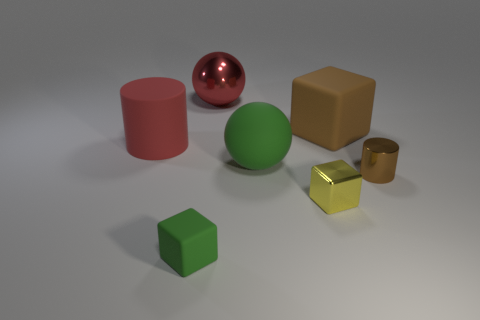Add 3 big red metallic balls. How many objects exist? 10 Subtract all balls. How many objects are left? 5 Subtract 1 green blocks. How many objects are left? 6 Subtract all purple cylinders. Subtract all tiny green cubes. How many objects are left? 6 Add 1 small green blocks. How many small green blocks are left? 2 Add 6 yellow shiny cylinders. How many yellow shiny cylinders exist? 6 